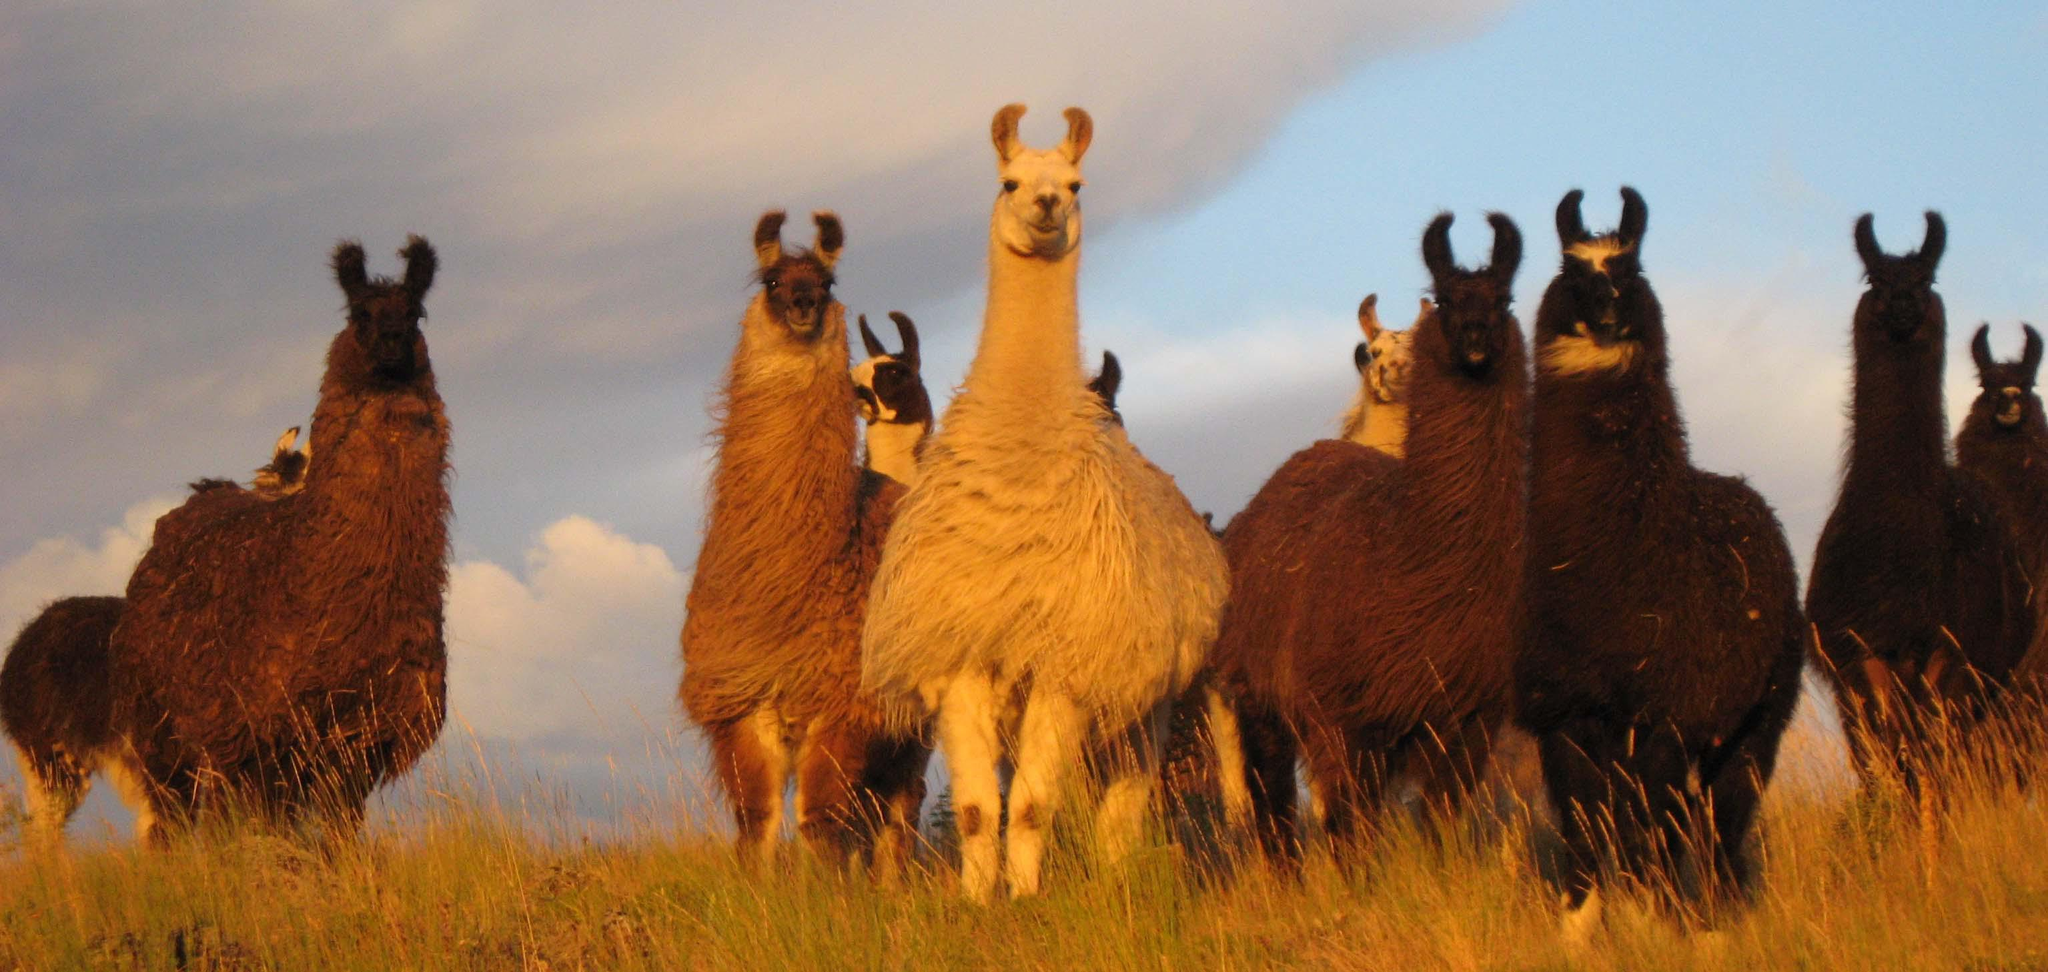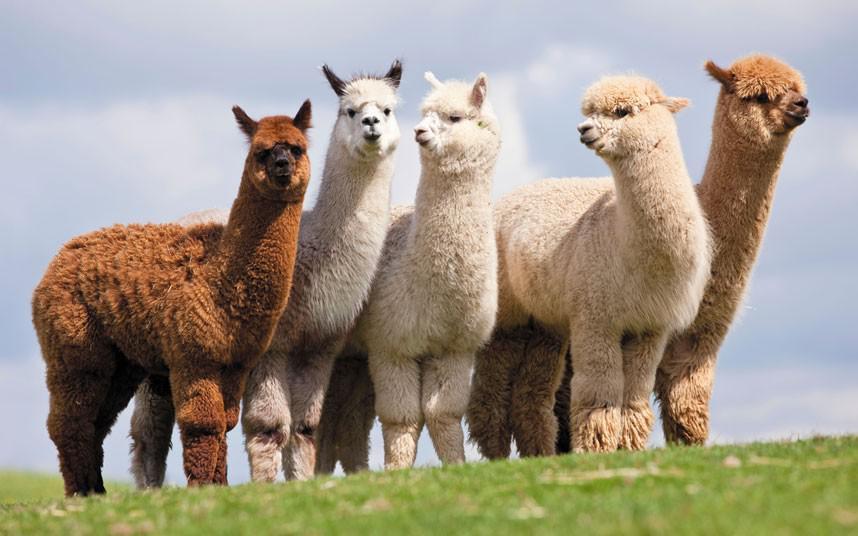The first image is the image on the left, the second image is the image on the right. For the images shown, is this caption "There is a single alpaca in one image and multiple ones in the other." true? Answer yes or no. No. The first image is the image on the left, the second image is the image on the right. Analyze the images presented: Is the assertion "The left image features exactly one light-colored llama, and the right image shows a group of at least nine llamas, most of them standing in profile." valid? Answer yes or no. No. 